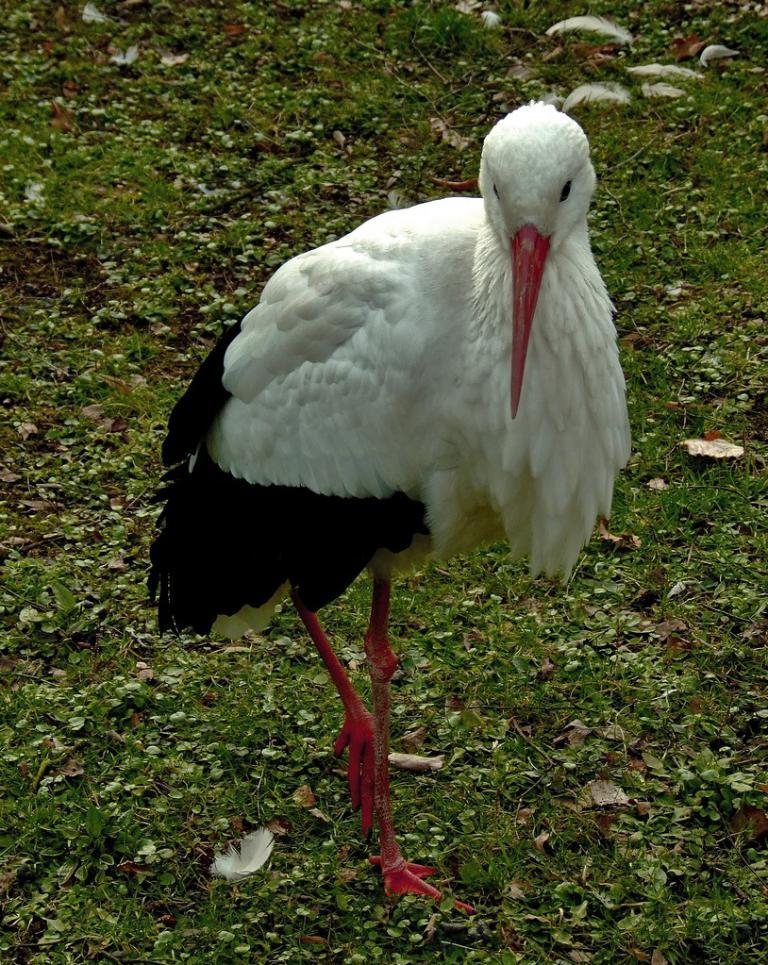What type of bird is standing in the image? There is a white stork standing in the image. What is the color of the grass in the image? The grass in the image is green in color. What type of nerve can be seen in the image? There is no nerve present in the image; it features a white stork standing on green grass. Are there any snails visible in the image? There are no snails visible in the image; it features a white stork standing on green grass. 